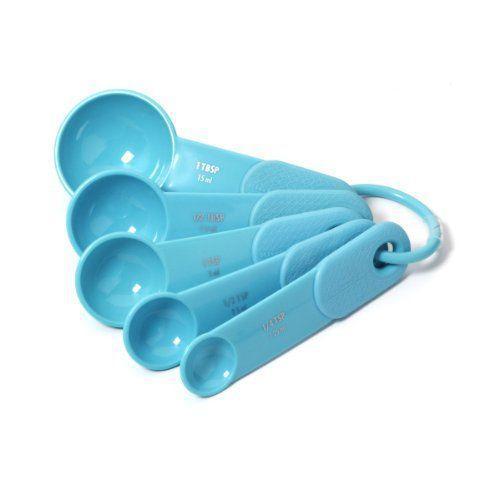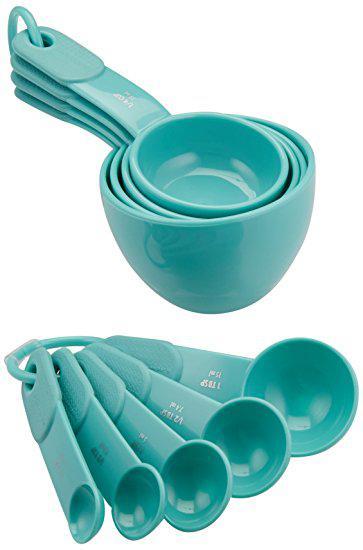The first image is the image on the left, the second image is the image on the right. For the images shown, is this caption "One image shows solid color plastic measuring cups and spoons." true? Answer yes or no. Yes. 